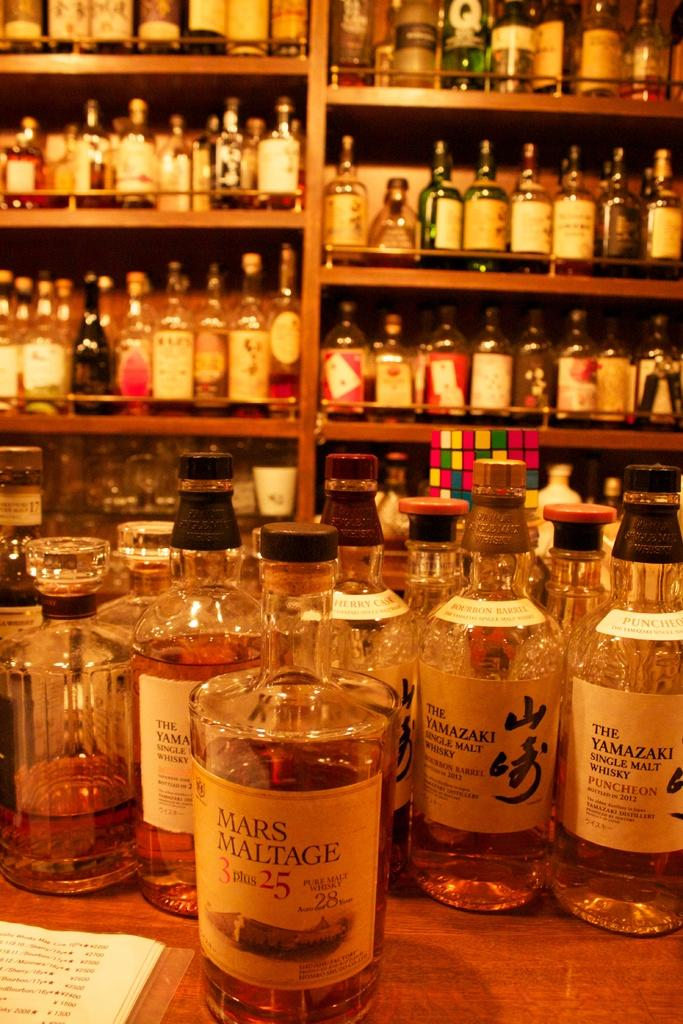<image>
Write a terse but informative summary of the picture. Many different kinds of whisky are on the table in front of a wall of liqour including a bottle of Mars Maltage. 